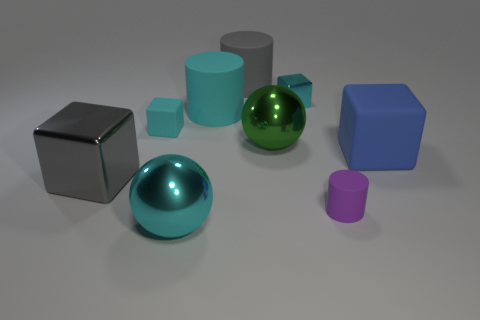Can you describe the lighting in the scene? The scene is lit from above, casting soft shadows beneath each object. The lighting appears uniform and soft, without strong directional shadows, suggesting a diffused light source, which results in a calm and evenly lit composition. 